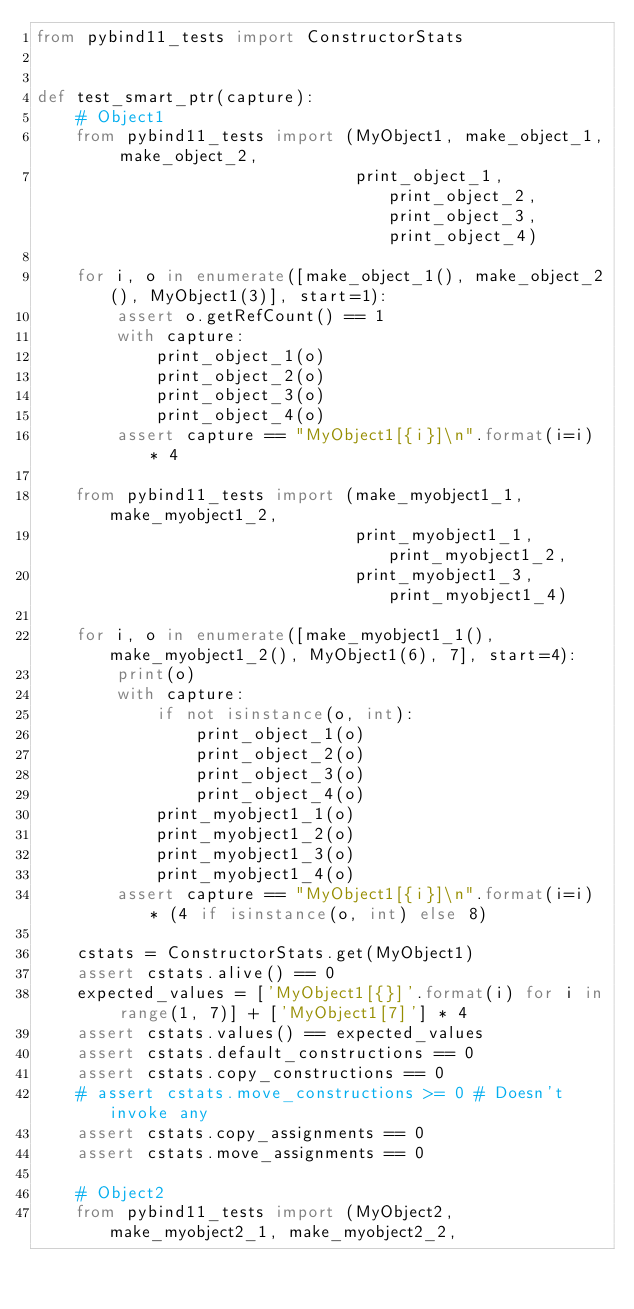<code> <loc_0><loc_0><loc_500><loc_500><_Python_>from pybind11_tests import ConstructorStats


def test_smart_ptr(capture):
    # Object1
    from pybind11_tests import (MyObject1, make_object_1, make_object_2,
                                print_object_1, print_object_2, print_object_3, print_object_4)

    for i, o in enumerate([make_object_1(), make_object_2(), MyObject1(3)], start=1):
        assert o.getRefCount() == 1
        with capture:
            print_object_1(o)
            print_object_2(o)
            print_object_3(o)
            print_object_4(o)
        assert capture == "MyObject1[{i}]\n".format(i=i) * 4

    from pybind11_tests import (make_myobject1_1, make_myobject1_2,
                                print_myobject1_1, print_myobject1_2,
                                print_myobject1_3, print_myobject1_4)

    for i, o in enumerate([make_myobject1_1(), make_myobject1_2(), MyObject1(6), 7], start=4):
        print(o)
        with capture:
            if not isinstance(o, int):
                print_object_1(o)
                print_object_2(o)
                print_object_3(o)
                print_object_4(o)
            print_myobject1_1(o)
            print_myobject1_2(o)
            print_myobject1_3(o)
            print_myobject1_4(o)
        assert capture == "MyObject1[{i}]\n".format(i=i) * (4 if isinstance(o, int) else 8)

    cstats = ConstructorStats.get(MyObject1)
    assert cstats.alive() == 0
    expected_values = ['MyObject1[{}]'.format(i) for i in range(1, 7)] + ['MyObject1[7]'] * 4
    assert cstats.values() == expected_values
    assert cstats.default_constructions == 0
    assert cstats.copy_constructions == 0
    # assert cstats.move_constructions >= 0 # Doesn't invoke any
    assert cstats.copy_assignments == 0
    assert cstats.move_assignments == 0

    # Object2
    from pybind11_tests import (MyObject2, make_myobject2_1, make_myobject2_2,</code> 